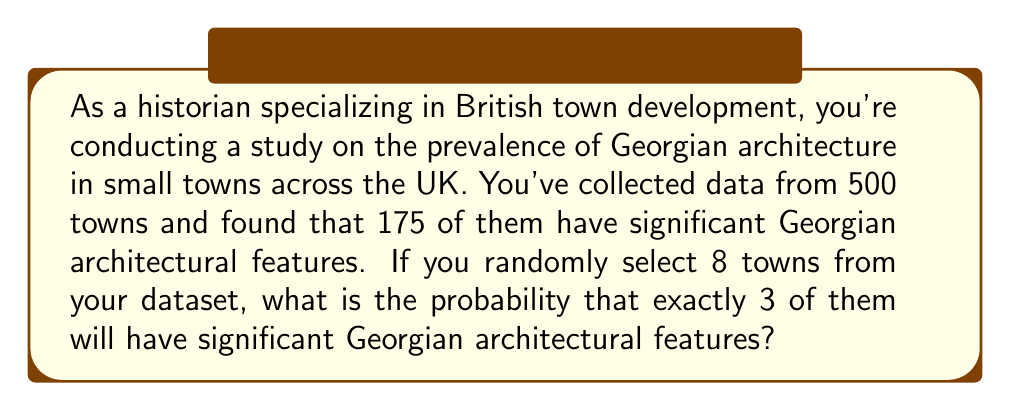Can you answer this question? To solve this problem, we need to use the binomial probability formula, as we're dealing with a fixed number of independent trials (selecting 8 towns) with two possible outcomes for each trial (having or not having significant Georgian features).

Let's define our variables:
$n = 8$ (number of towns selected)
$k = 3$ (number of successes we're looking for)
$p = 175/500 = 0.35$ (probability of a town having significant Georgian features)
$q = 1 - p = 0.65$ (probability of a town not having significant Georgian features)

The binomial probability formula is:

$$ P(X = k) = \binom{n}{k} p^k q^{n-k} $$

Where $\binom{n}{k}$ is the binomial coefficient, calculated as:

$$ \binom{n}{k} = \frac{n!}{k!(n-k)!} $$

Let's calculate step by step:

1) First, calculate the binomial coefficient:
   $$ \binom{8}{3} = \frac{8!}{3!(8-3)!} = \frac{8!}{3!5!} = 56 $$

2) Now, let's plug everything into the binomial probability formula:
   $$ P(X = 3) = 56 \cdot (0.35)^3 \cdot (0.65)^{8-3} $$
   $$ = 56 \cdot (0.35)^3 \cdot (0.65)^5 $$

3) Calculate the powers:
   $$ = 56 \cdot 0.042875 \cdot 0.116150 $$

4) Multiply all terms:
   $$ = 0.2784 $$

Therefore, the probability of exactly 3 out of 8 randomly selected towns having significant Georgian architectural features is approximately 0.2784 or 27.84%.
Answer: 0.2784 or 27.84% 